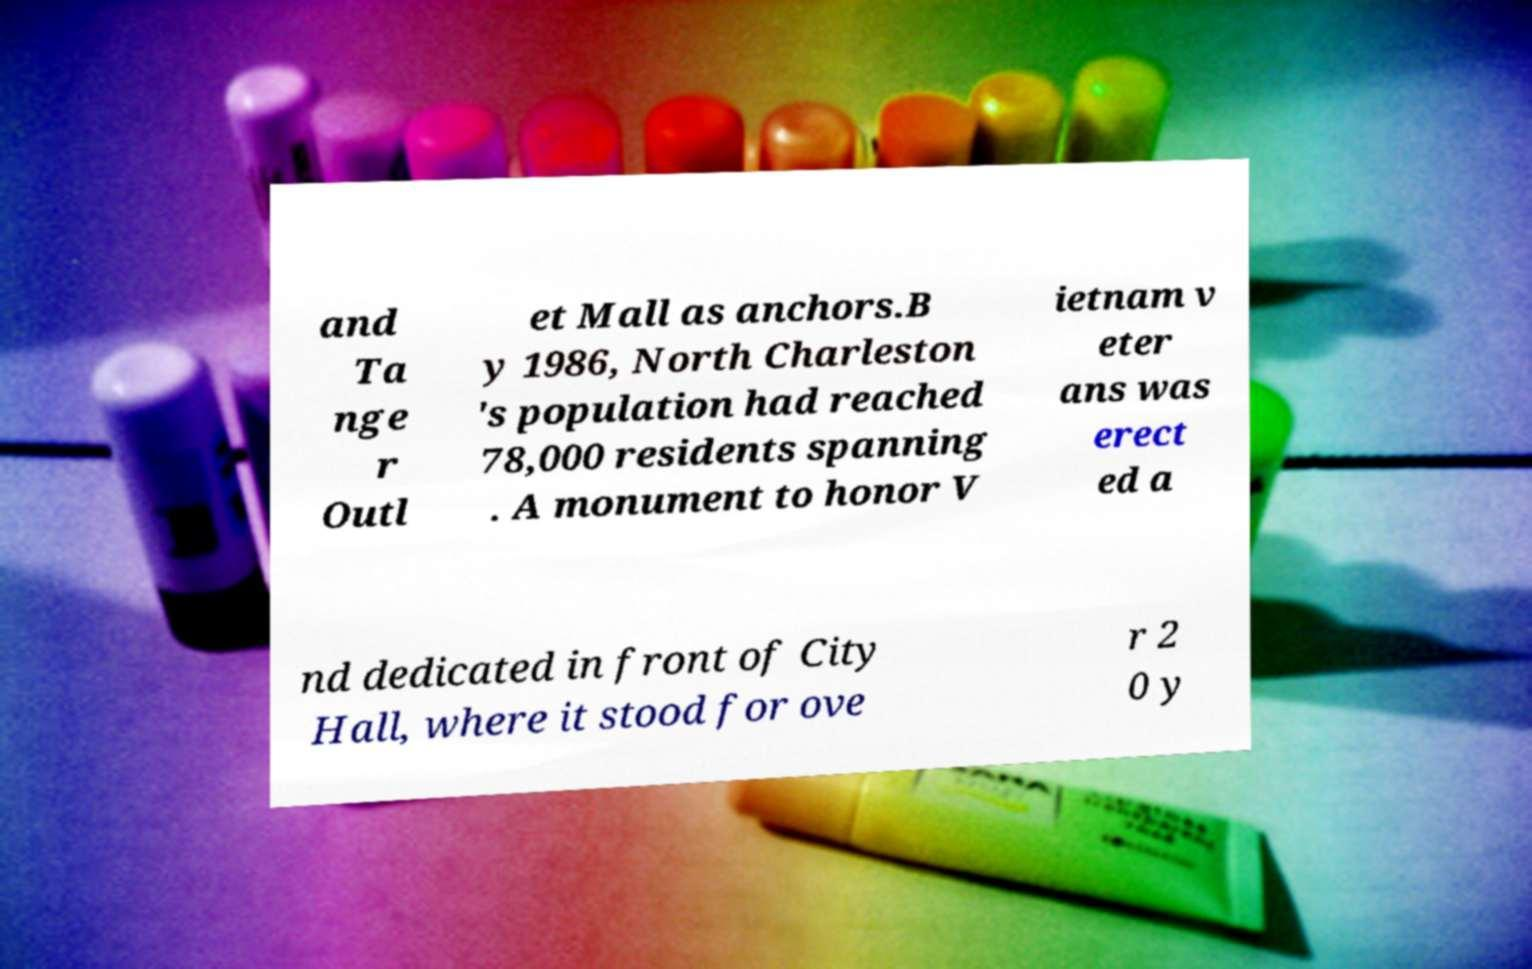Can you accurately transcribe the text from the provided image for me? and Ta nge r Outl et Mall as anchors.B y 1986, North Charleston 's population had reached 78,000 residents spanning . A monument to honor V ietnam v eter ans was erect ed a nd dedicated in front of City Hall, where it stood for ove r 2 0 y 